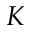<formula> <loc_0><loc_0><loc_500><loc_500>K</formula> 